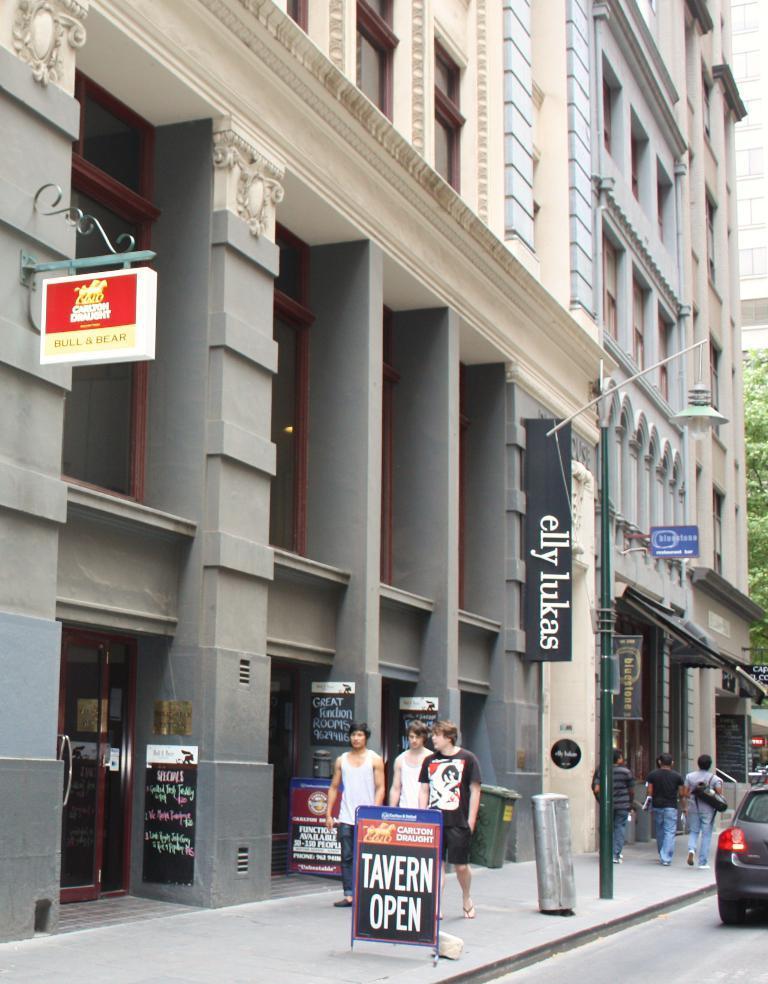Could you give a brief overview of what you see in this image? In front of the image there is a car on the road. There are people walking on the pavement. There are boards with some text on it. There are trash cans and a light pole. In the background of the image there are buildings and trees. 